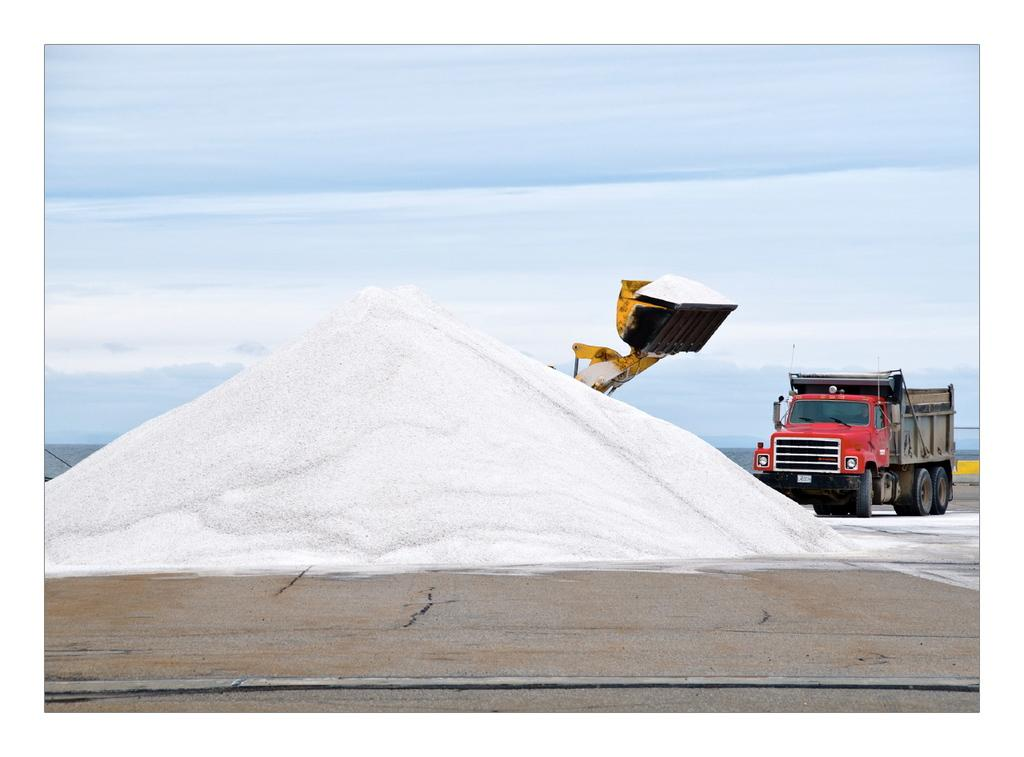What is the white material in the image? There is a material in white color in the image, but the specific type is not mentioned. Where is the lorry located in the image? The lorry is on the right side of the image. What type of vehicle is present in the image? There is a vehicle in the image, but the specific type is not mentioned. How is the sky depicted in the image? The sky is blue with clouds in the image. What type of cream is being applied to the material in the image? There is no cream being applied to the material in the image. 